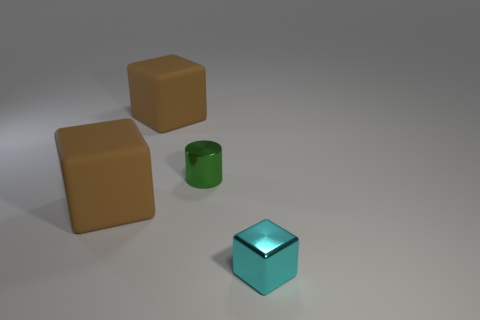Are there an equal number of cylinders that are behind the green shiny thing and cubes?
Provide a succinct answer. No. What number of other things are there of the same material as the green cylinder
Your response must be concise. 1. There is a brown thing that is in front of the tiny cylinder; does it have the same size as the metal object to the left of the tiny cyan cube?
Keep it short and to the point. No. What number of objects are either brown matte cubes that are in front of the cylinder or brown blocks that are in front of the small cylinder?
Ensure brevity in your answer.  1. Is there any other thing that is the same shape as the cyan object?
Keep it short and to the point. Yes. Is the color of the large rubber block that is in front of the tiny green metal cylinder the same as the object behind the small green cylinder?
Your response must be concise. Yes. What number of rubber things are either cyan blocks or large blocks?
Offer a terse response. 2. Are there any other things that are the same size as the shiny block?
Offer a terse response. Yes. What shape is the large rubber thing that is behind the metal thing that is left of the small metal block?
Offer a very short reply. Cube. Do the brown block behind the small cylinder and the tiny thing on the left side of the small cyan shiny cube have the same material?
Give a very brief answer. No. 